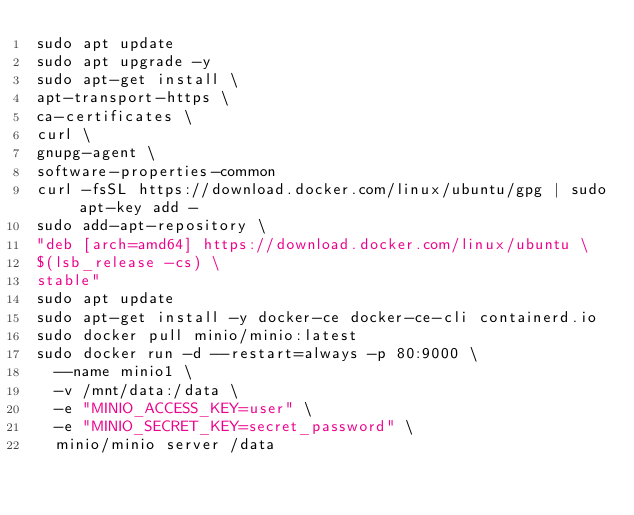<code> <loc_0><loc_0><loc_500><loc_500><_Bash_>sudo apt update
sudo apt upgrade -y
sudo apt-get install \
apt-transport-https \
ca-certificates \
curl \
gnupg-agent \
software-properties-common
curl -fsSL https://download.docker.com/linux/ubuntu/gpg | sudo apt-key add -
sudo add-apt-repository \
"deb [arch=amd64] https://download.docker.com/linux/ubuntu \
$(lsb_release -cs) \
stable"
sudo apt update
sudo apt-get install -y docker-ce docker-ce-cli containerd.io
sudo docker pull minio/minio:latest
sudo docker run -d --restart=always -p 80:9000 \
  --name minio1 \
  -v /mnt/data:/data \
  -e "MINIO_ACCESS_KEY=user" \
  -e "MINIO_SECRET_KEY=secret_password" \
  minio/minio server /data
</code> 